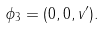Convert formula to latex. <formula><loc_0><loc_0><loc_500><loc_500>\phi _ { 3 } = ( 0 , 0 , v ^ { \prime } ) .</formula> 